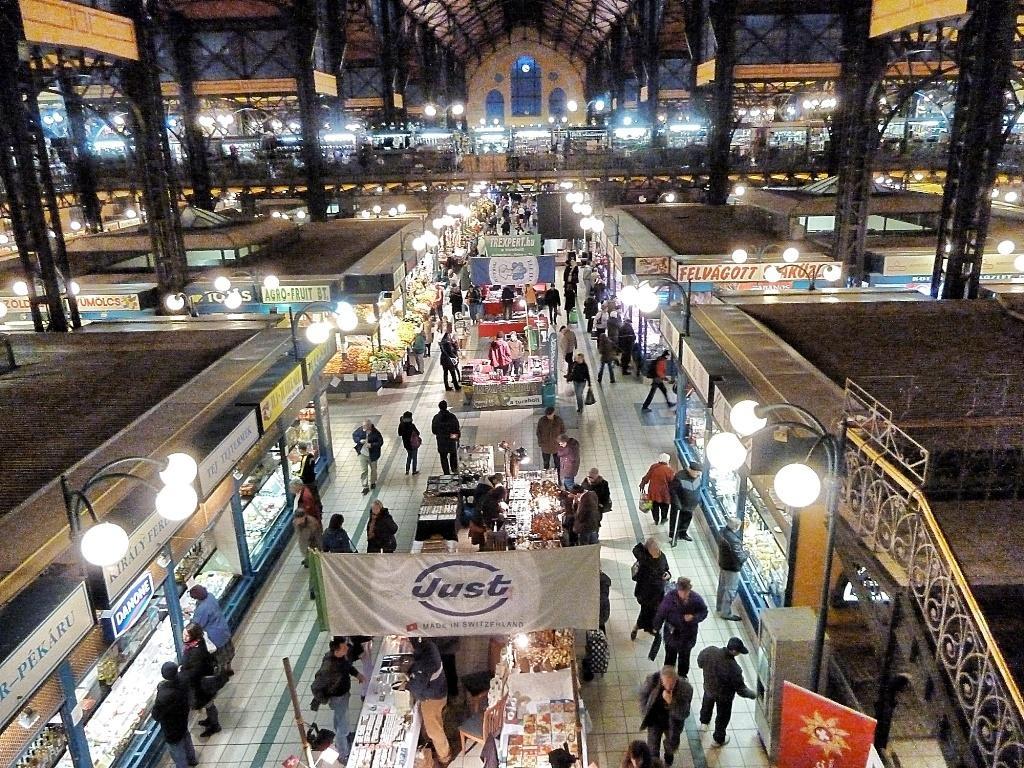Could you give a brief overview of what you see in this image? This is a top view of an image where we can see these people are walking on the floor, we can see stalls, light poles, banners, boards, iron pillars and the building in the background. 